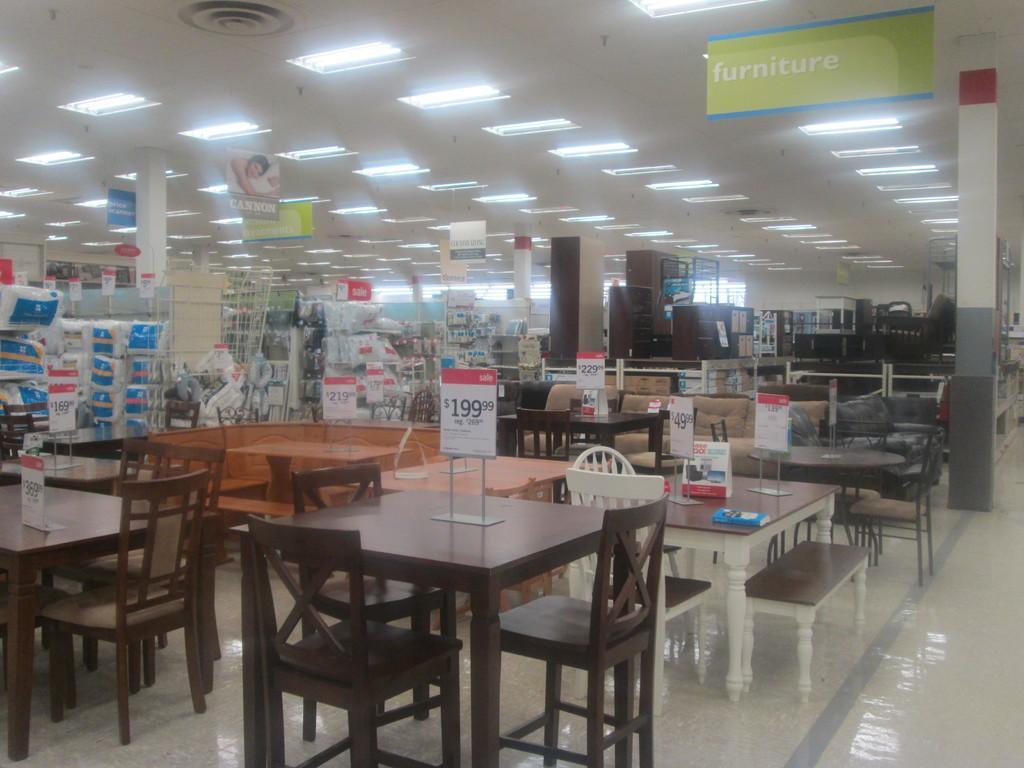How would you summarize this image in a sentence or two? In this image there is a shop, in that shop there are table and chairs, in the background there are racks, in that racks there are some items, on the top there is a ceiling and lights. 